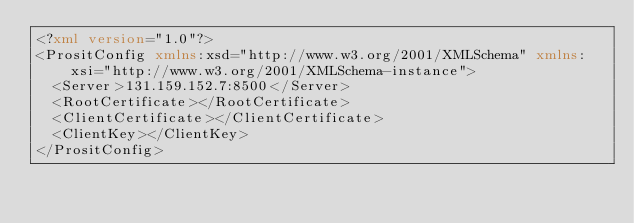<code> <loc_0><loc_0><loc_500><loc_500><_XML_><?xml version="1.0"?>
<PrositConfig xmlns:xsd="http://www.w3.org/2001/XMLSchema" xmlns:xsi="http://www.w3.org/2001/XMLSchema-instance">
  <Server>131.159.152.7:8500</Server>
  <RootCertificate></RootCertificate>
  <ClientCertificate></ClientCertificate>
  <ClientKey></ClientKey>
</PrositConfig></code> 